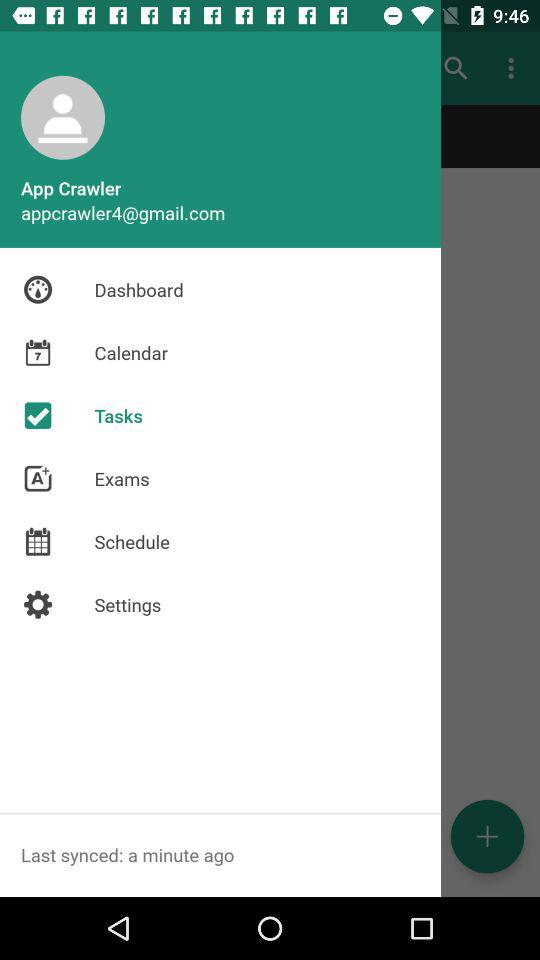How many exams have been completed?
When the provided information is insufficient, respond with <no answer>. <no answer> 